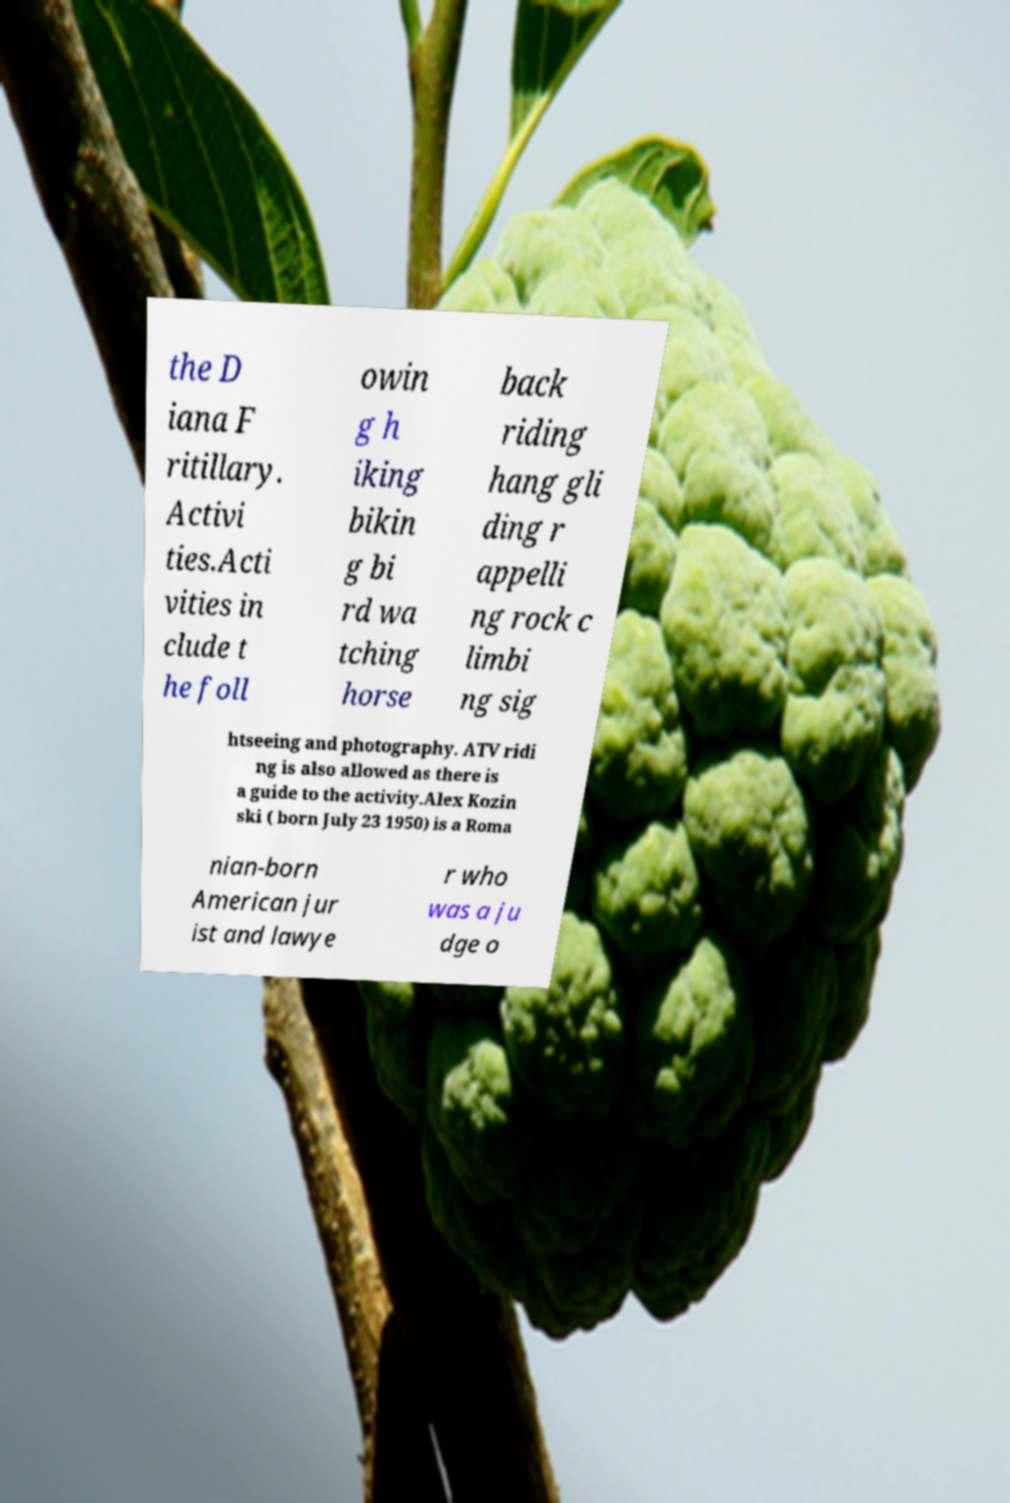I need the written content from this picture converted into text. Can you do that? the D iana F ritillary. Activi ties.Acti vities in clude t he foll owin g h iking bikin g bi rd wa tching horse back riding hang gli ding r appelli ng rock c limbi ng sig htseeing and photography. ATV ridi ng is also allowed as there is a guide to the activity.Alex Kozin ski ( born July 23 1950) is a Roma nian-born American jur ist and lawye r who was a ju dge o 